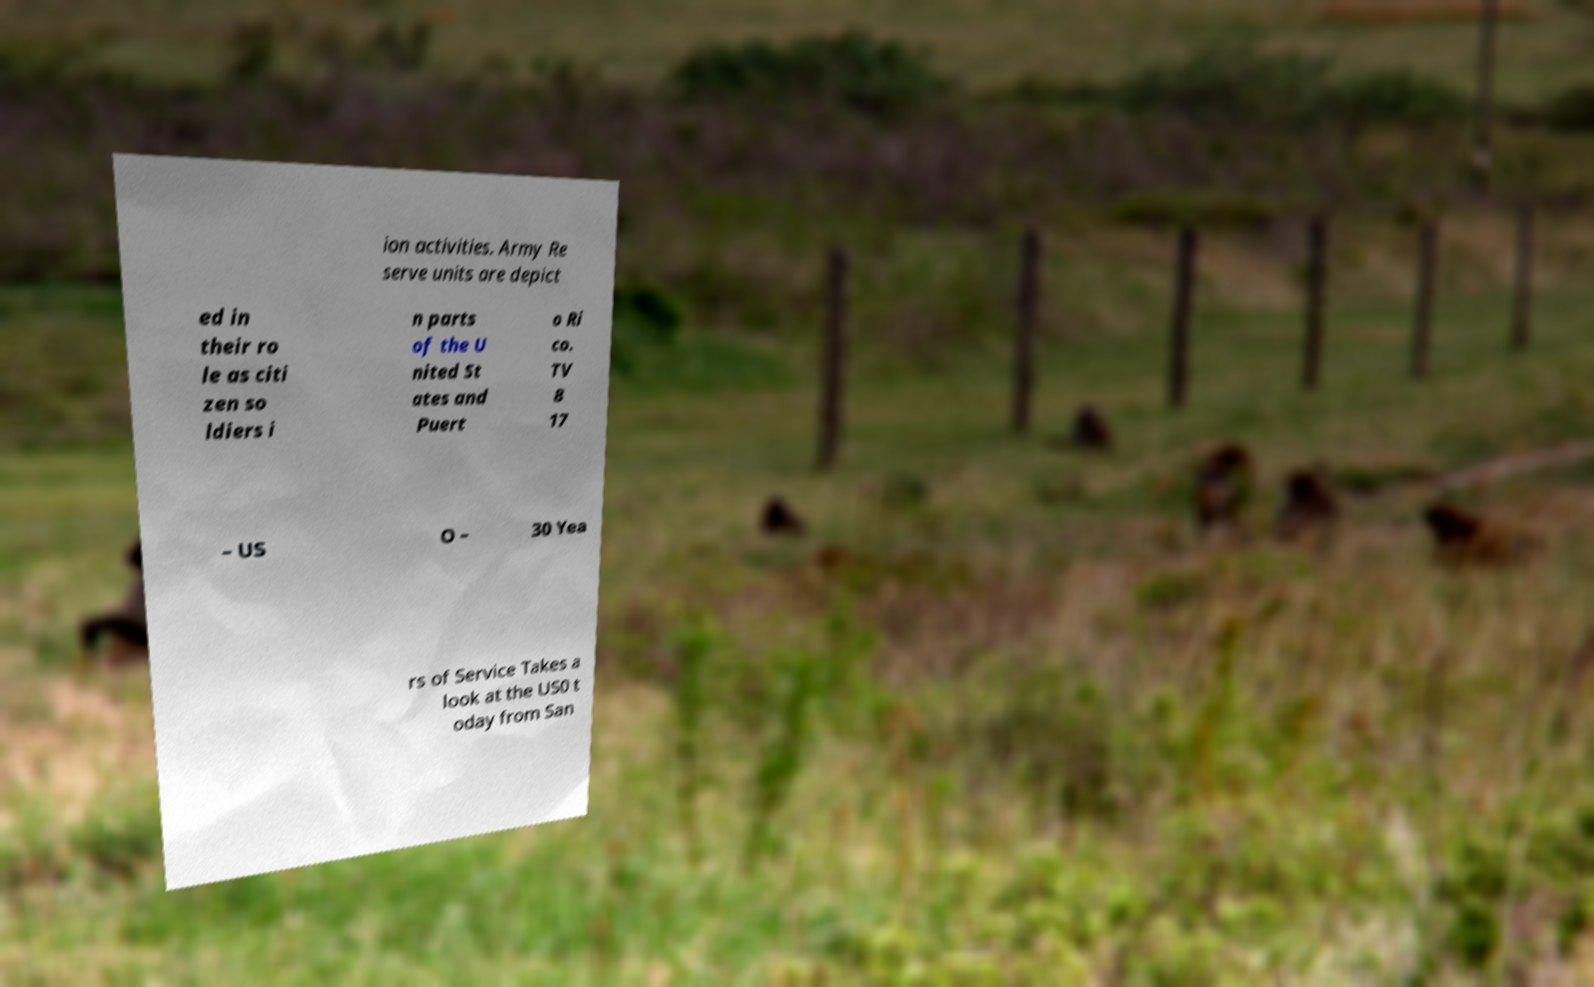I need the written content from this picture converted into text. Can you do that? ion activities. Army Re serve units are depict ed in their ro le as citi zen so ldiers i n parts of the U nited St ates and Puert o Ri co. TV 8 17 – US O – 30 Yea rs of Service Takes a look at the US0 t oday from San 